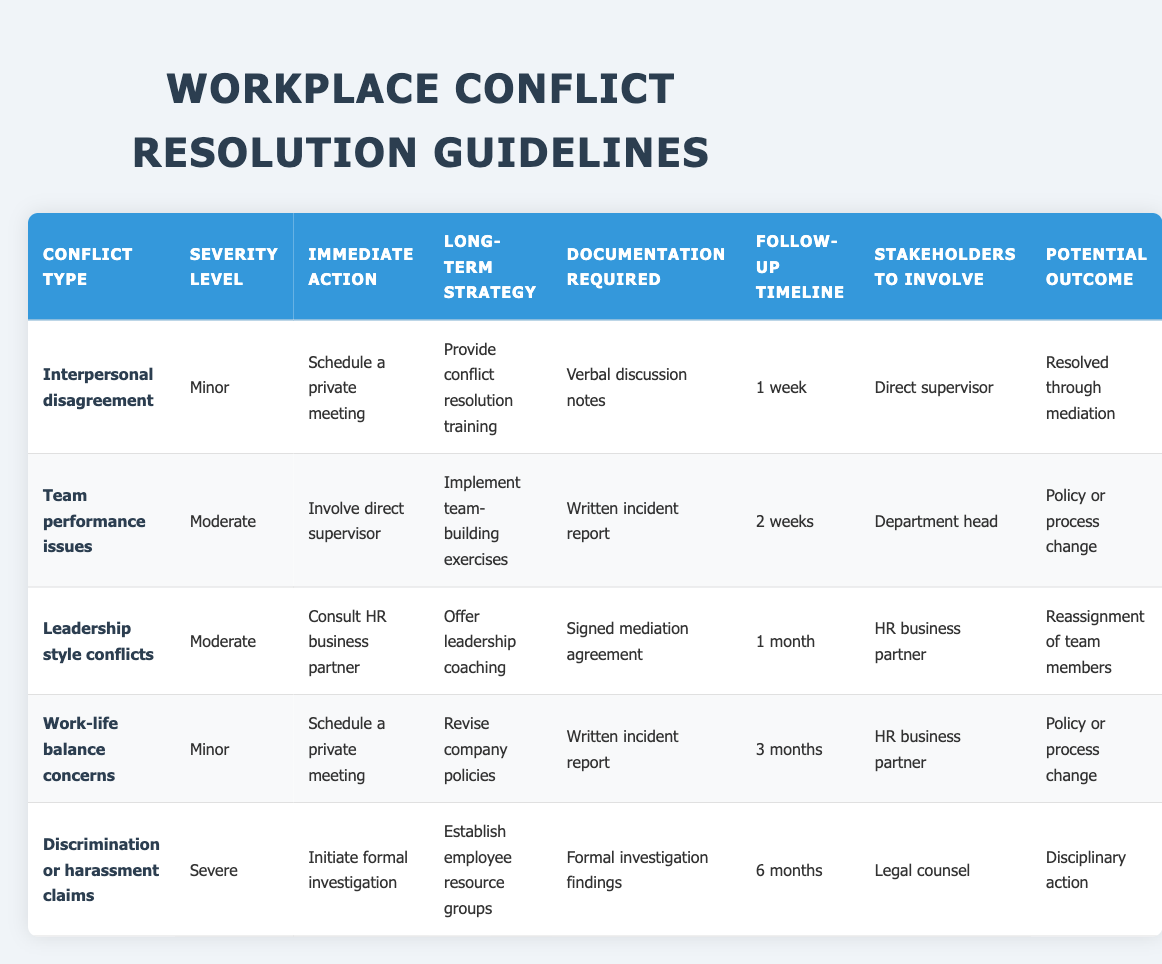What are the immediate actions for minor interpersonal disagreements? According to the table, for minor interpersonal disagreements, the immediate action is to schedule a private meeting.
Answer: Schedule a private meeting How many follow-up timelines are there listed? The table lists five follow-up timelines: 1 week, 2 weeks, 1 month, 3 months, and 6 months. Therefore, there are a total of five timelines.
Answer: 5 Is a signed mediation agreement required for leadership style conflicts? Yes, a signed mediation agreement is listed as the documentation required for leadership style conflicts.
Answer: Yes What long-term strategy is associated with severe discrimination or harassment claims? The long-term strategy associated with severe discrimination or harassment claims is to establish employee resource groups.
Answer: Establish employee resource groups If a team performance issue is considered moderate, what is the immediate action to be taken? For moderate team performance issues, the immediate action would be to involve the direct supervisor.
Answer: Involve direct supervisor Are there any potential outcomes that involve disciplinary action? Yes, one of the potential outcomes listed is disciplinary action in the case of severe discrimination or harassment claims.
Answer: Yes Which conflict type has a follow-up timeline of 3 months? The conflict type with a follow-up timeline of 3 months is work-life balance concerns.
Answer: Work-life balance concerns What is the documentation requirement for moderate team performance issues? For moderate team performance issues, the documentation requirement is a written incident report.
Answer: Written incident report Which stakeholders are involved if there is a severe discrimination or harassment claim? For a severe discrimination or harassment claim, the stakeholders to involve are legal counsel.
Answer: Legal counsel 